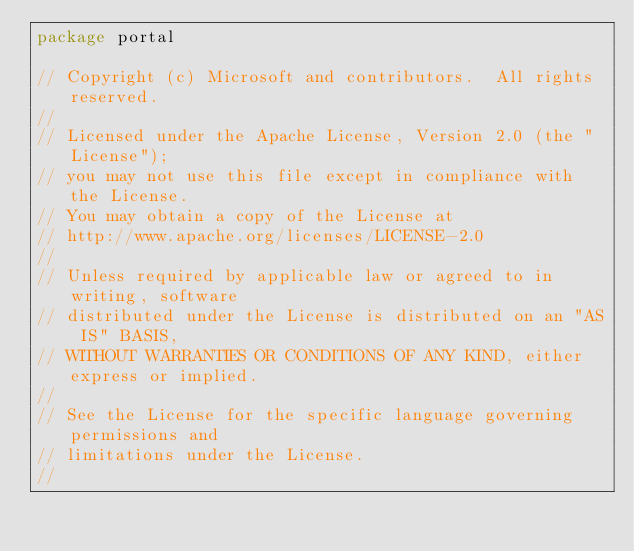<code> <loc_0><loc_0><loc_500><loc_500><_Go_>package portal

// Copyright (c) Microsoft and contributors.  All rights reserved.
//
// Licensed under the Apache License, Version 2.0 (the "License");
// you may not use this file except in compliance with the License.
// You may obtain a copy of the License at
// http://www.apache.org/licenses/LICENSE-2.0
//
// Unless required by applicable law or agreed to in writing, software
// distributed under the License is distributed on an "AS IS" BASIS,
// WITHOUT WARRANTIES OR CONDITIONS OF ANY KIND, either express or implied.
//
// See the License for the specific language governing permissions and
// limitations under the License.
//</code> 